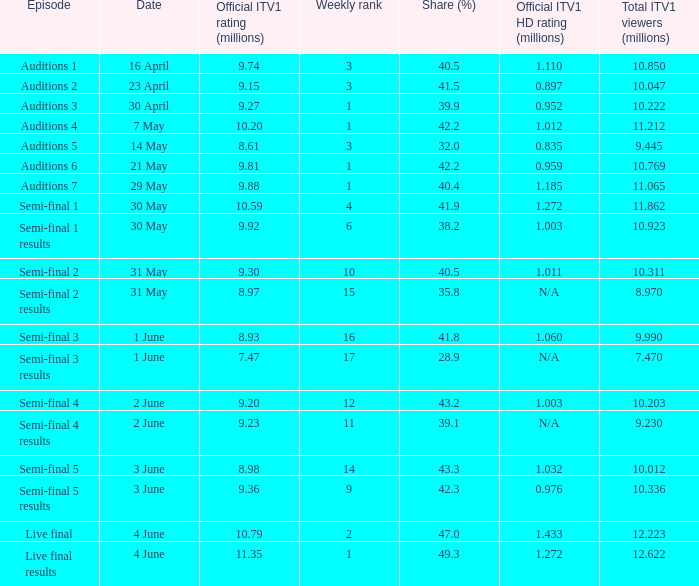Which episode had an official ITV1 HD rating of 1.185 million?  Auditions 7. 